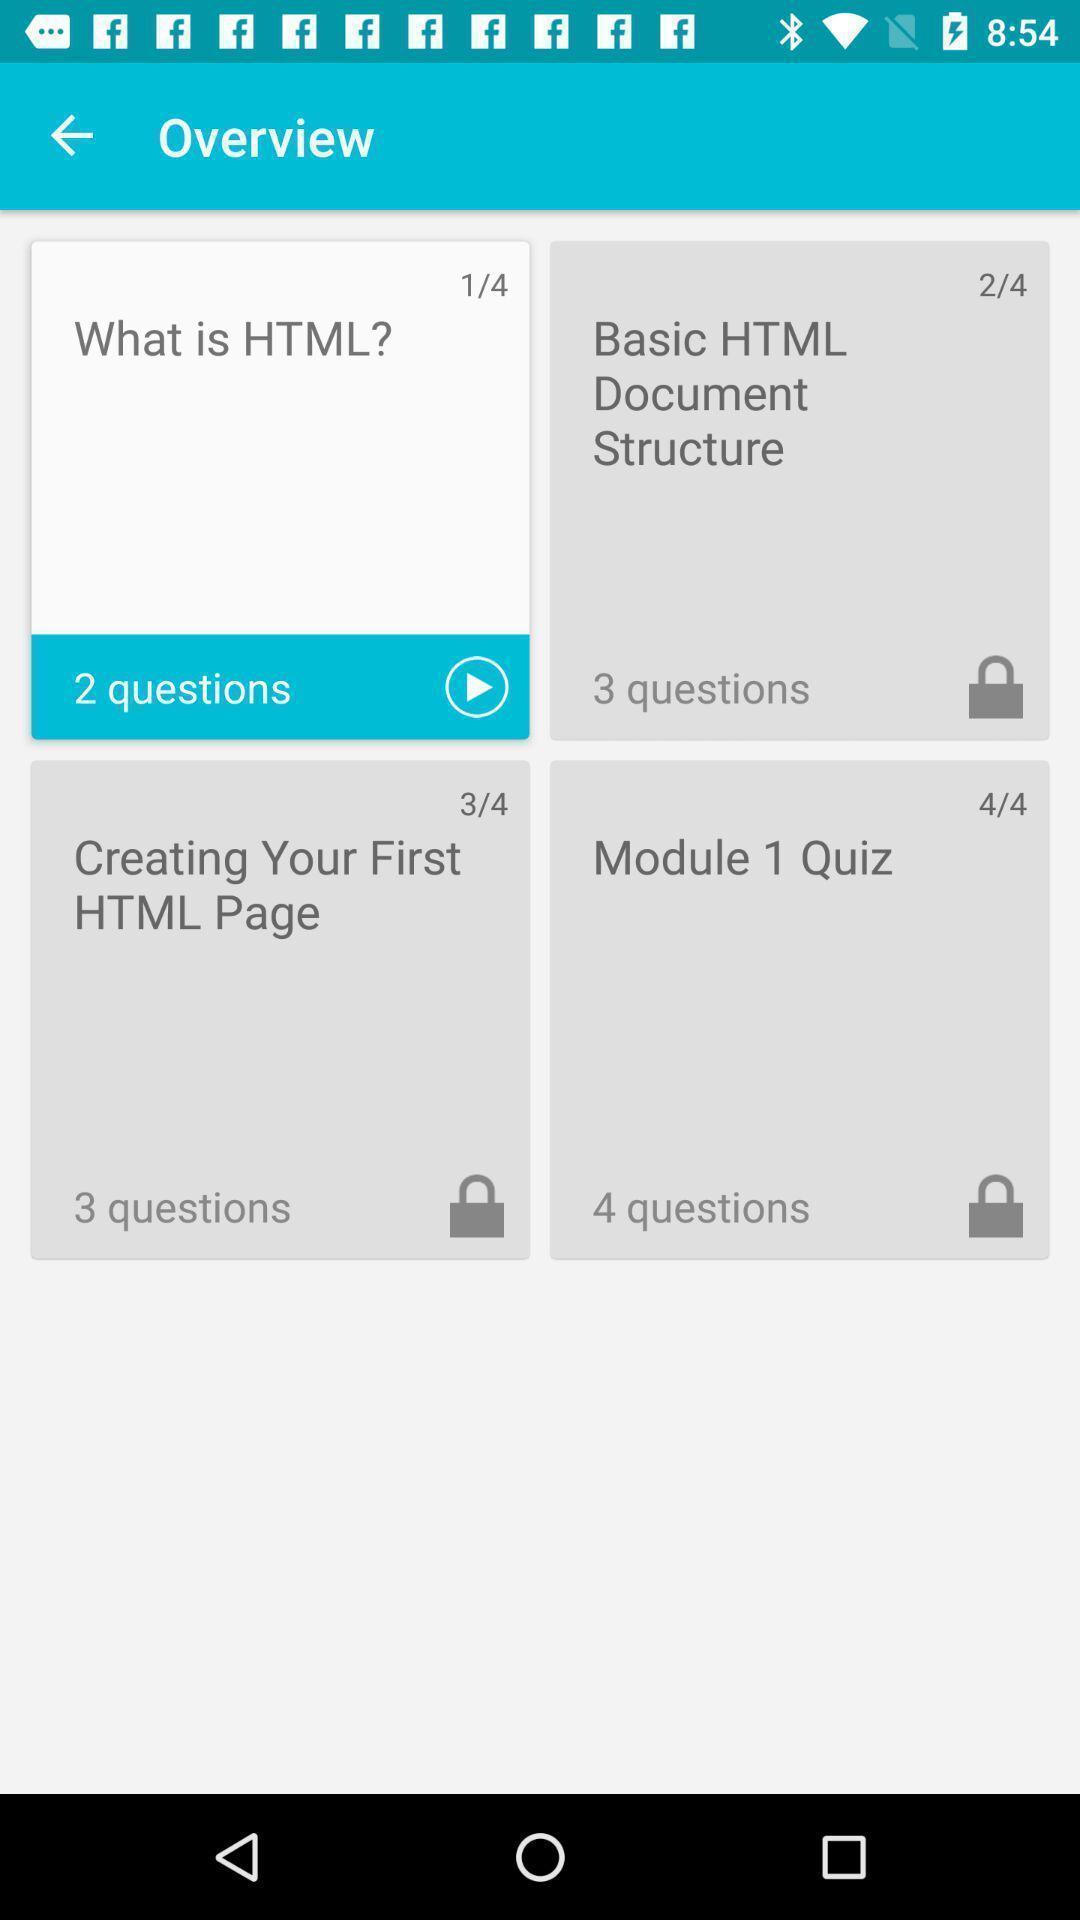Explain the elements present in this screenshot. Screen show an overview of a html topic. 